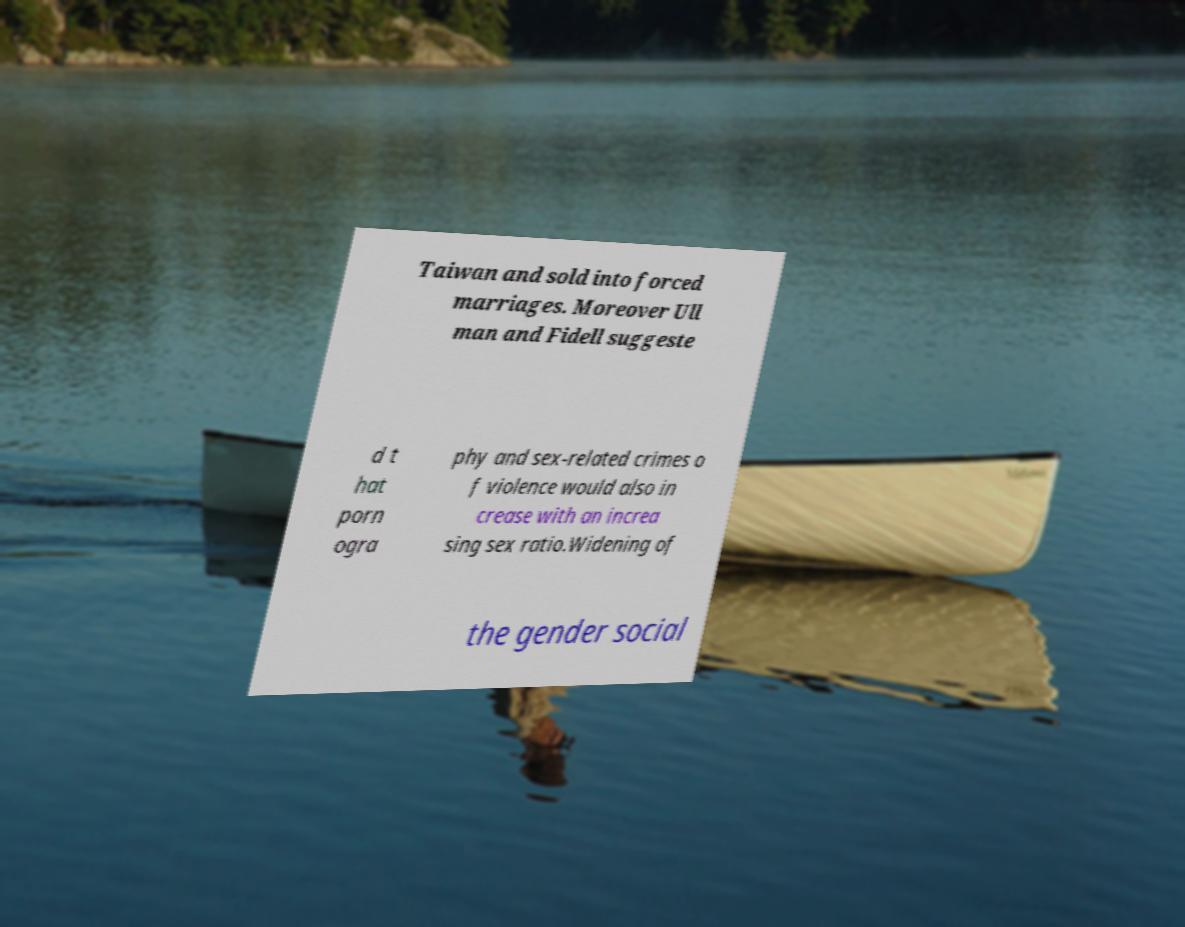For documentation purposes, I need the text within this image transcribed. Could you provide that? Taiwan and sold into forced marriages. Moreover Ull man and Fidell suggeste d t hat porn ogra phy and sex-related crimes o f violence would also in crease with an increa sing sex ratio.Widening of the gender social 